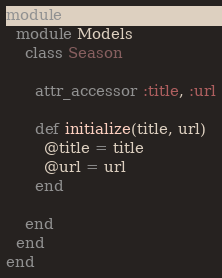<code> <loc_0><loc_0><loc_500><loc_500><_Ruby_>module Popmovies
  module Models
    class Season

      attr_accessor :title, :url

      def initialize(title, url)
        @title = title
        @url = url
      end

    end
  end
end
</code> 